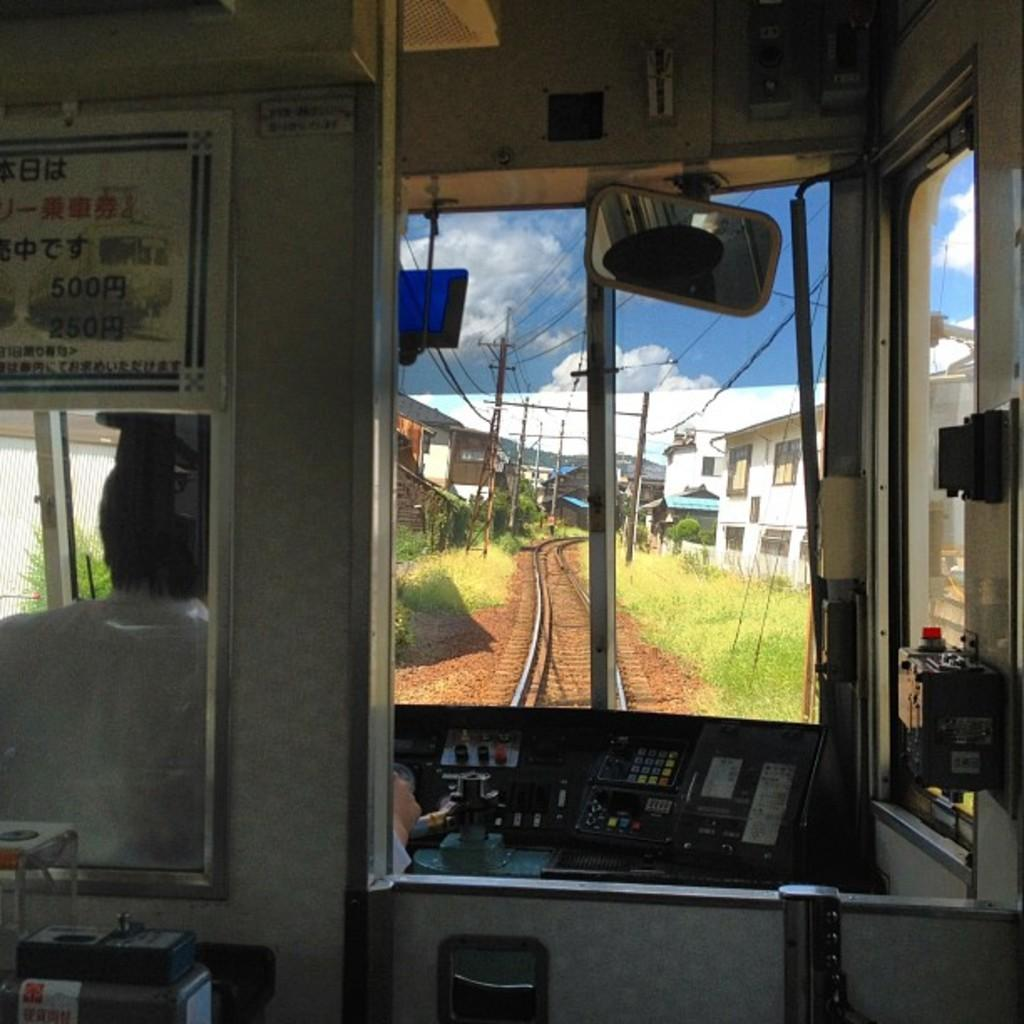What is the main object in the image? There is a board in the image. What part of a vehicle is present in the image? There is a windshield in the image. Can you describe the person in the image? There is a person in the image. What mechanical component is visible in the image? A: There is an engine in the image. What reflective surface is present in the image? There is a mirror in the image. What is the girl arguing about with the person in the image? There is no girl or argument present in the image. 